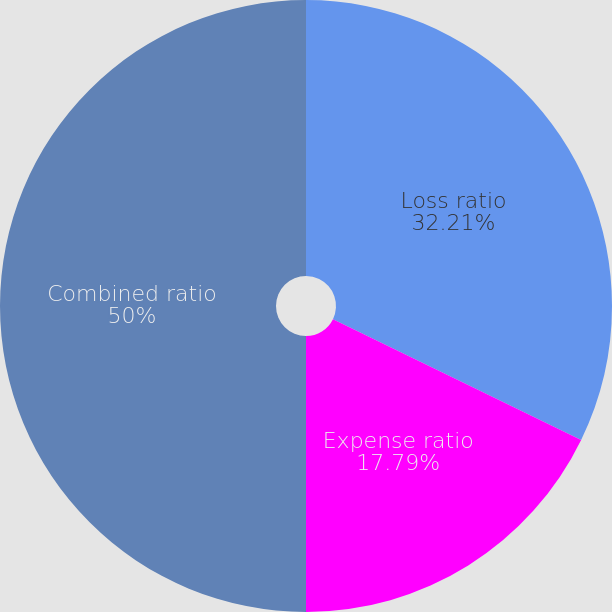Convert chart. <chart><loc_0><loc_0><loc_500><loc_500><pie_chart><fcel>Loss ratio<fcel>Expense ratio<fcel>Combined ratio<nl><fcel>32.21%<fcel>17.79%<fcel>50.0%<nl></chart> 